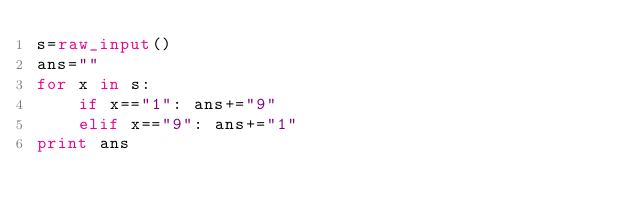<code> <loc_0><loc_0><loc_500><loc_500><_Python_>s=raw_input()
ans=""
for x in s:
	if x=="1": ans+="9"
	elif x=="9": ans+="1"
print ans</code> 